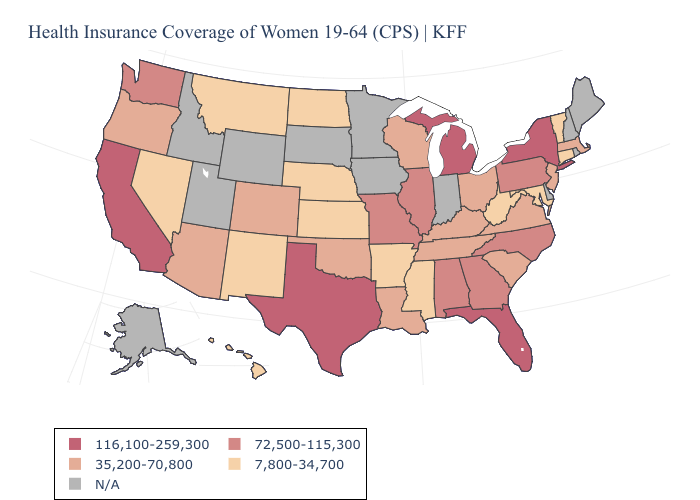Does the first symbol in the legend represent the smallest category?
Write a very short answer. No. What is the value of Texas?
Answer briefly. 116,100-259,300. What is the highest value in the USA?
Be succinct. 116,100-259,300. Does Montana have the lowest value in the USA?
Give a very brief answer. Yes. Name the states that have a value in the range 116,100-259,300?
Keep it brief. California, Florida, Michigan, New York, Texas. What is the lowest value in the USA?
Give a very brief answer. 7,800-34,700. Does Pennsylvania have the lowest value in the USA?
Write a very short answer. No. Which states hav the highest value in the MidWest?
Short answer required. Michigan. Name the states that have a value in the range 35,200-70,800?
Answer briefly. Arizona, Colorado, Kentucky, Louisiana, Massachusetts, New Jersey, Ohio, Oklahoma, Oregon, South Carolina, Tennessee, Virginia, Wisconsin. Among the states that border Massachusetts , which have the highest value?
Concise answer only. New York. Does Vermont have the lowest value in the Northeast?
Answer briefly. Yes. Does Texas have the highest value in the USA?
Be succinct. Yes. What is the value of California?
Give a very brief answer. 116,100-259,300. What is the lowest value in the USA?
Be succinct. 7,800-34,700. 